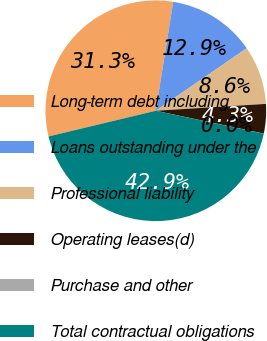Convert chart to OTSL. <chart><loc_0><loc_0><loc_500><loc_500><pie_chart><fcel>Long-term debt including<fcel>Loans outstanding under the<fcel>Professional liability<fcel>Operating leases(d)<fcel>Purchase and other<fcel>Total contractual obligations<nl><fcel>31.26%<fcel>12.89%<fcel>8.6%<fcel>4.31%<fcel>0.02%<fcel>42.91%<nl></chart> 